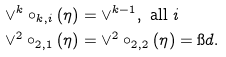<formula> <loc_0><loc_0><loc_500><loc_500>\vee ^ { k } \circ _ { k , i } ( \eta ) & = \vee ^ { k - 1 } , \text { all } i \\ \vee ^ { 2 } \circ _ { 2 , 1 } ( \eta ) & = \vee ^ { 2 } \circ _ { 2 , 2 } ( \eta ) = \i d . \\</formula> 